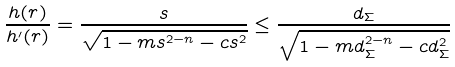Convert formula to latex. <formula><loc_0><loc_0><loc_500><loc_500>\frac { h ( r ) } { h ^ { \prime } ( r ) } = \frac { s } { \sqrt { 1 - m s ^ { 2 - n } - c s ^ { 2 } } } \leq \frac { d _ { \Sigma } } { \sqrt { 1 - m d _ { \Sigma } ^ { 2 - n } - c d _ { \Sigma } ^ { 2 } } }</formula> 